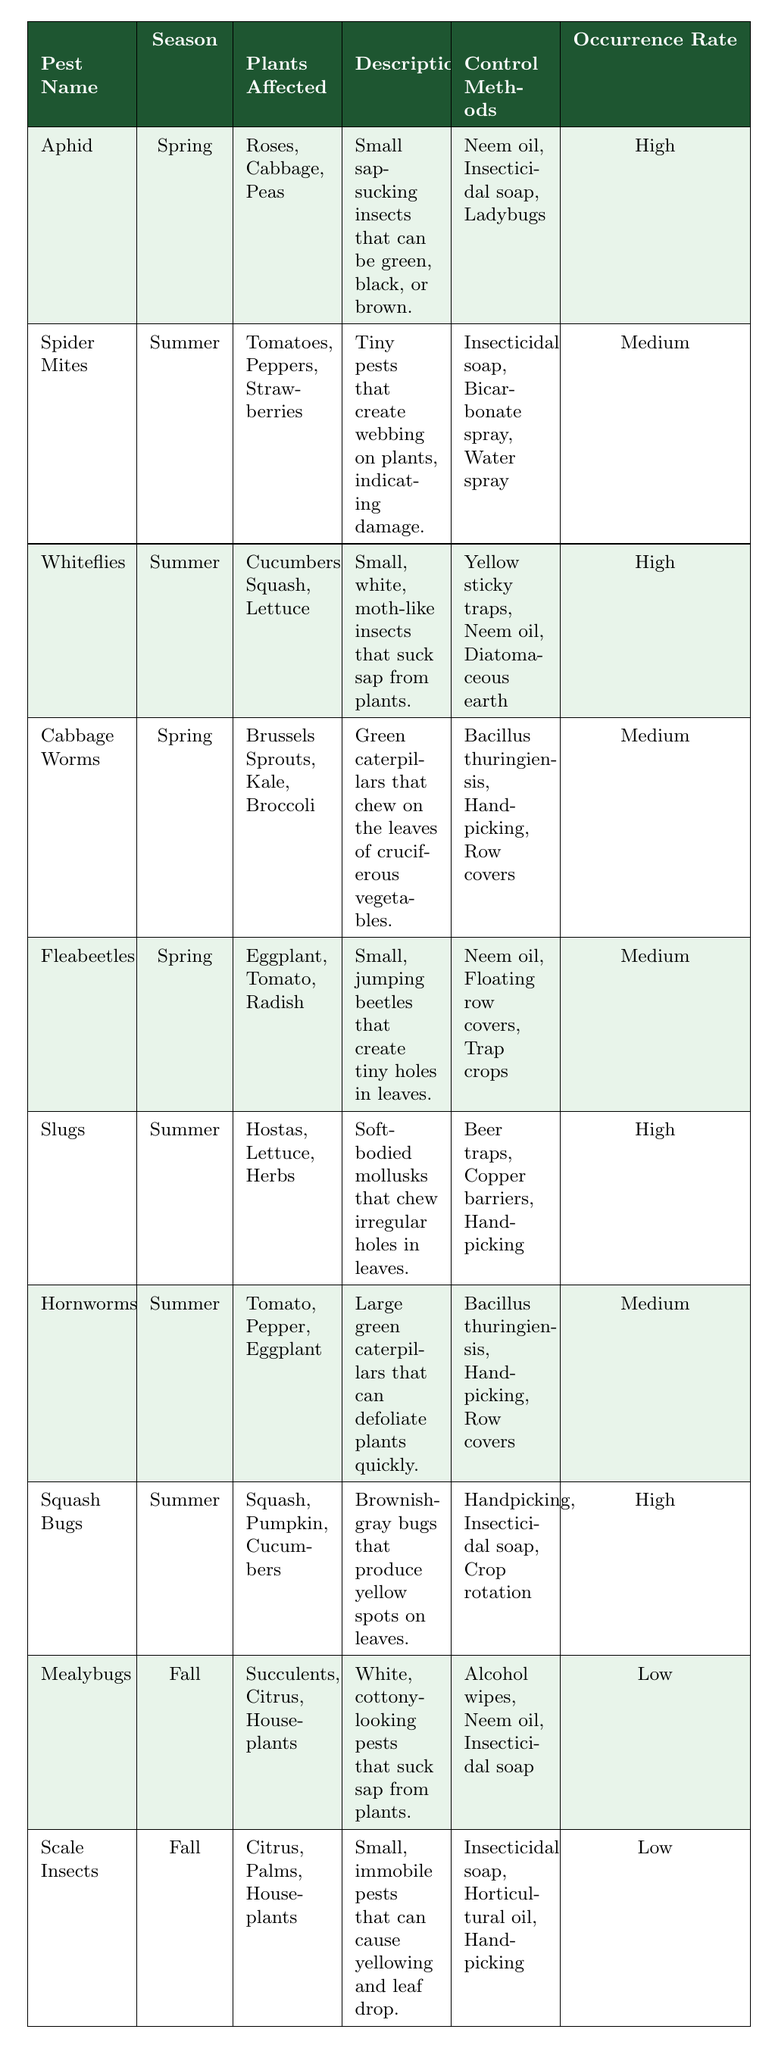What pest is associated with a high occurrence rate in the summer? By reviewing the table, both Slugs and Squash Bugs have a high occurrence rate listed for the summer season.
Answer: Slugs and Squash Bugs Which pests affect roses in the spring? The table indicates that Aphids affect Roses, and they are present in the spring season.
Answer: Aphids How many pests have a low occurrence rate? From the table, only Mealybugs and Scale Insects are listed with a low occurrence rate, which totals to 2.
Answer: 2 Is it true that Hornworms are associated with a medium occurrence rate? According to the table, Hornworms are indeed categorized with a medium occurrence rate.
Answer: Yes What is the common control method for both Whiteflies and Slugs? By checking the control methods listed for both pests, Neem oil is the common control method used for both Whiteflies and Slugs.
Answer: Neem oil Name one plant affected by Cabbage Worms in the spring. The table shows that Brussels Sprouts is one of the plants affected by Cabbage Worms, which are present in spring.
Answer: Brussels Sprouts Which season has the most pests listed in the table? By counting the occurrences in the table, summer lists 4 pests (Spider Mites, Whiteflies, Slugs, Hornworms, Squash Bugs) while spring has 3 (Aphid, Cabbage Worms, Fleabeetles) and fall has 2 (Mealybugs, Scale Insects), making summer the season with the highest numbers.
Answer: Summer What method is most commonly used to control pests in spring? When looking at the control methods used for pests in spring, Neem oil appears in Aphid, Fleabeetles, and Cabbage Worms, making it a common choice.
Answer: Neem oil Which pest has a descriptive phrase indicating it can create webbing on plants? The table describes Spider Mites as tiny pests that create webbing on plants to indicate damage.
Answer: Spider Mites List the plants affected by Squash Bugs. The table lists Squash, Pumpkin, and Cucumbers as the plants affected by Squash Bugs.
Answer: Squash, Pumpkin, Cucumbers 